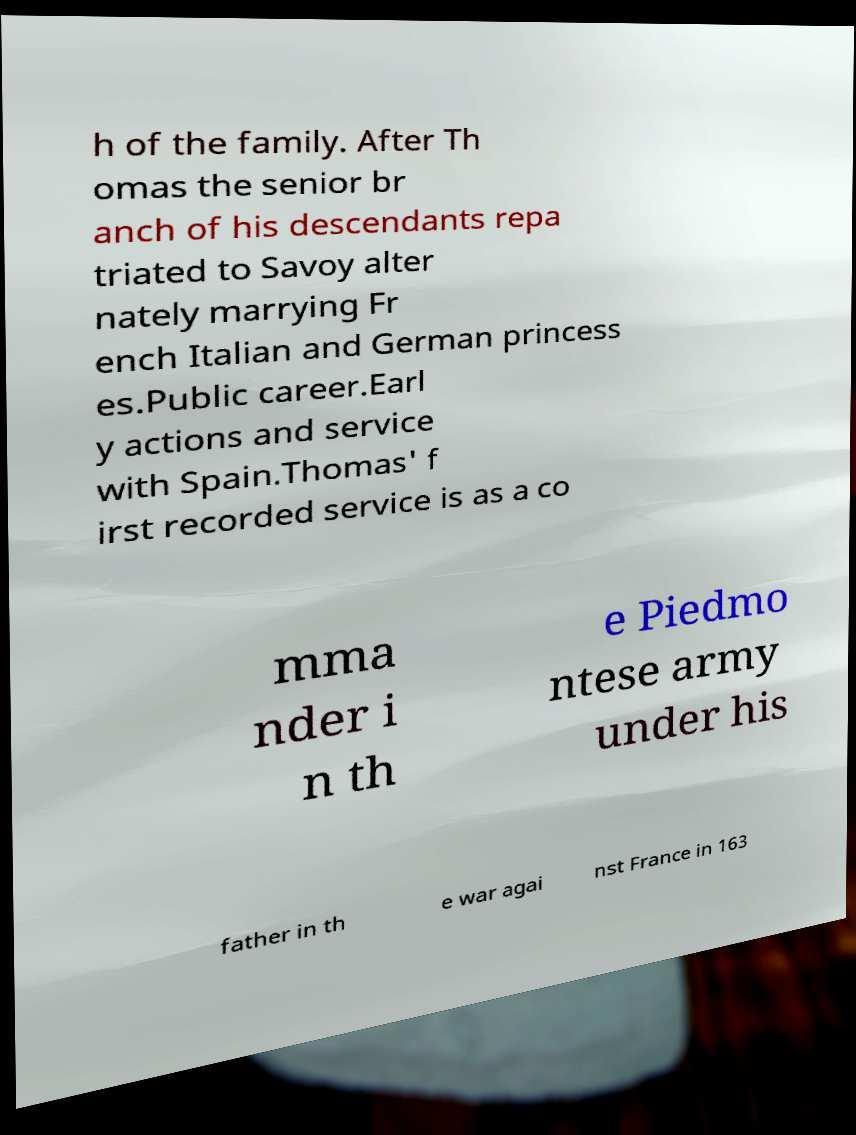Please read and relay the text visible in this image. What does it say? h of the family. After Th omas the senior br anch of his descendants repa triated to Savoy alter nately marrying Fr ench Italian and German princess es.Public career.Earl y actions and service with Spain.Thomas' f irst recorded service is as a co mma nder i n th e Piedmo ntese army under his father in th e war agai nst France in 163 